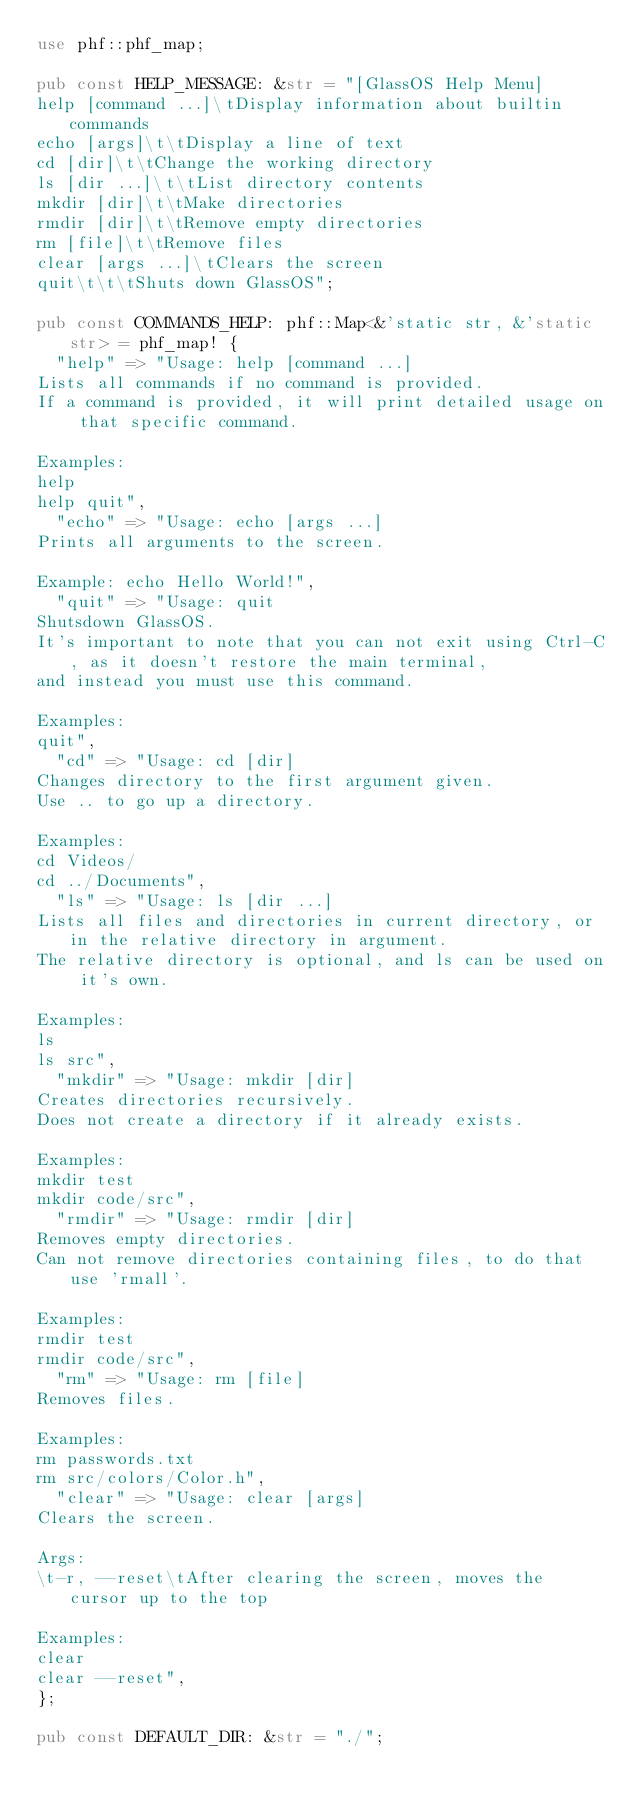Convert code to text. <code><loc_0><loc_0><loc_500><loc_500><_Rust_>use phf::phf_map;

pub const HELP_MESSAGE: &str = "[GlassOS Help Menu]
help [command ...]\tDisplay information about builtin commands
echo [args]\t\tDisplay a line of text
cd [dir]\t\tChange the working directory
ls [dir ...]\t\tList directory contents
mkdir [dir]\t\tMake directories
rmdir [dir]\t\tRemove empty directories
rm [file]\t\tRemove files
clear [args ...]\tClears the screen
quit\t\t\tShuts down GlassOS";

pub const COMMANDS_HELP: phf::Map<&'static str, &'static str> = phf_map! {
	"help" => "Usage: help [command ...]
Lists all commands if no command is provided.
If a command is provided, it will print detailed usage on that specific command.

Examples:
help
help quit",
	"echo" => "Usage: echo [args ...]
Prints all arguments to the screen.

Example: echo Hello World!",
	"quit" => "Usage: quit
Shutsdown GlassOS.
It's important to note that you can not exit using Ctrl-C, as it doesn't restore the main terminal,
and instead you must use this command.

Examples:
quit",
	"cd" => "Usage: cd [dir]
Changes directory to the first argument given.
Use .. to go up a directory.

Examples:
cd Videos/
cd ../Documents",
	"ls" => "Usage: ls [dir ...]
Lists all files and directories in current directory, or in the relative directory in argument.
The relative directory is optional, and ls can be used on it's own.

Examples:
ls
ls src",
	"mkdir" => "Usage: mkdir [dir]
Creates directories recursively.
Does not create a directory if it already exists.

Examples:
mkdir test
mkdir code/src",
	"rmdir" => "Usage: rmdir [dir]
Removes empty directories.
Can not remove directories containing files, to do that use 'rmall'.

Examples:
rmdir test
rmdir code/src",
	"rm" => "Usage: rm [file]
Removes files.

Examples:
rm passwords.txt
rm src/colors/Color.h",
	"clear" => "Usage: clear [args]
Clears the screen.

Args:
\t-r, --reset\tAfter clearing the screen, moves the cursor up to the top

Examples:
clear
clear --reset",
};

pub const DEFAULT_DIR: &str = "./";</code> 